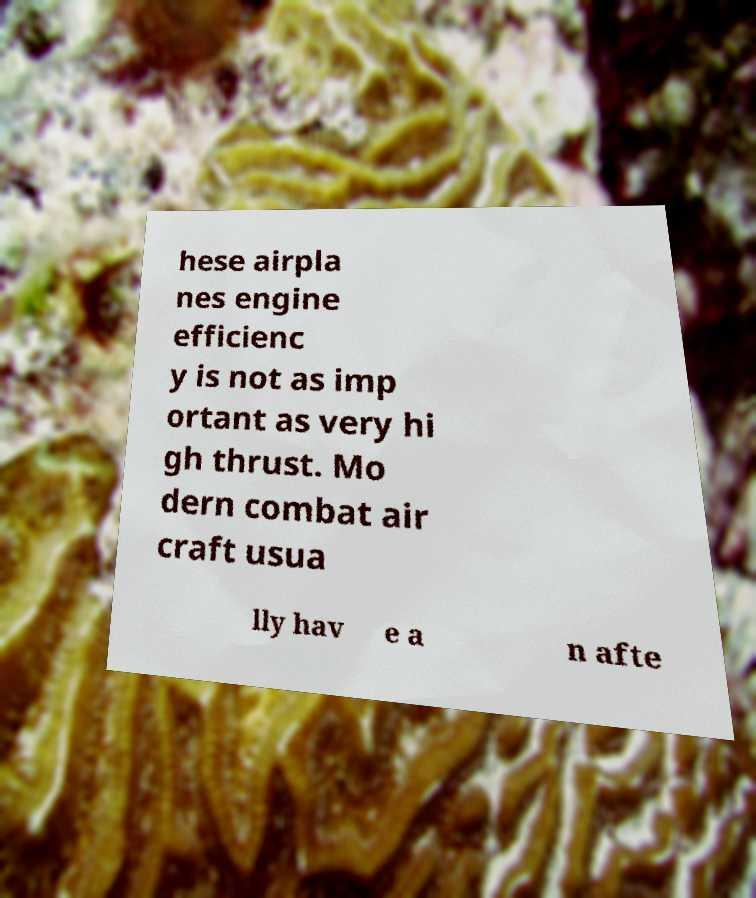For documentation purposes, I need the text within this image transcribed. Could you provide that? hese airpla nes engine efficienc y is not as imp ortant as very hi gh thrust. Mo dern combat air craft usua lly hav e a n afte 